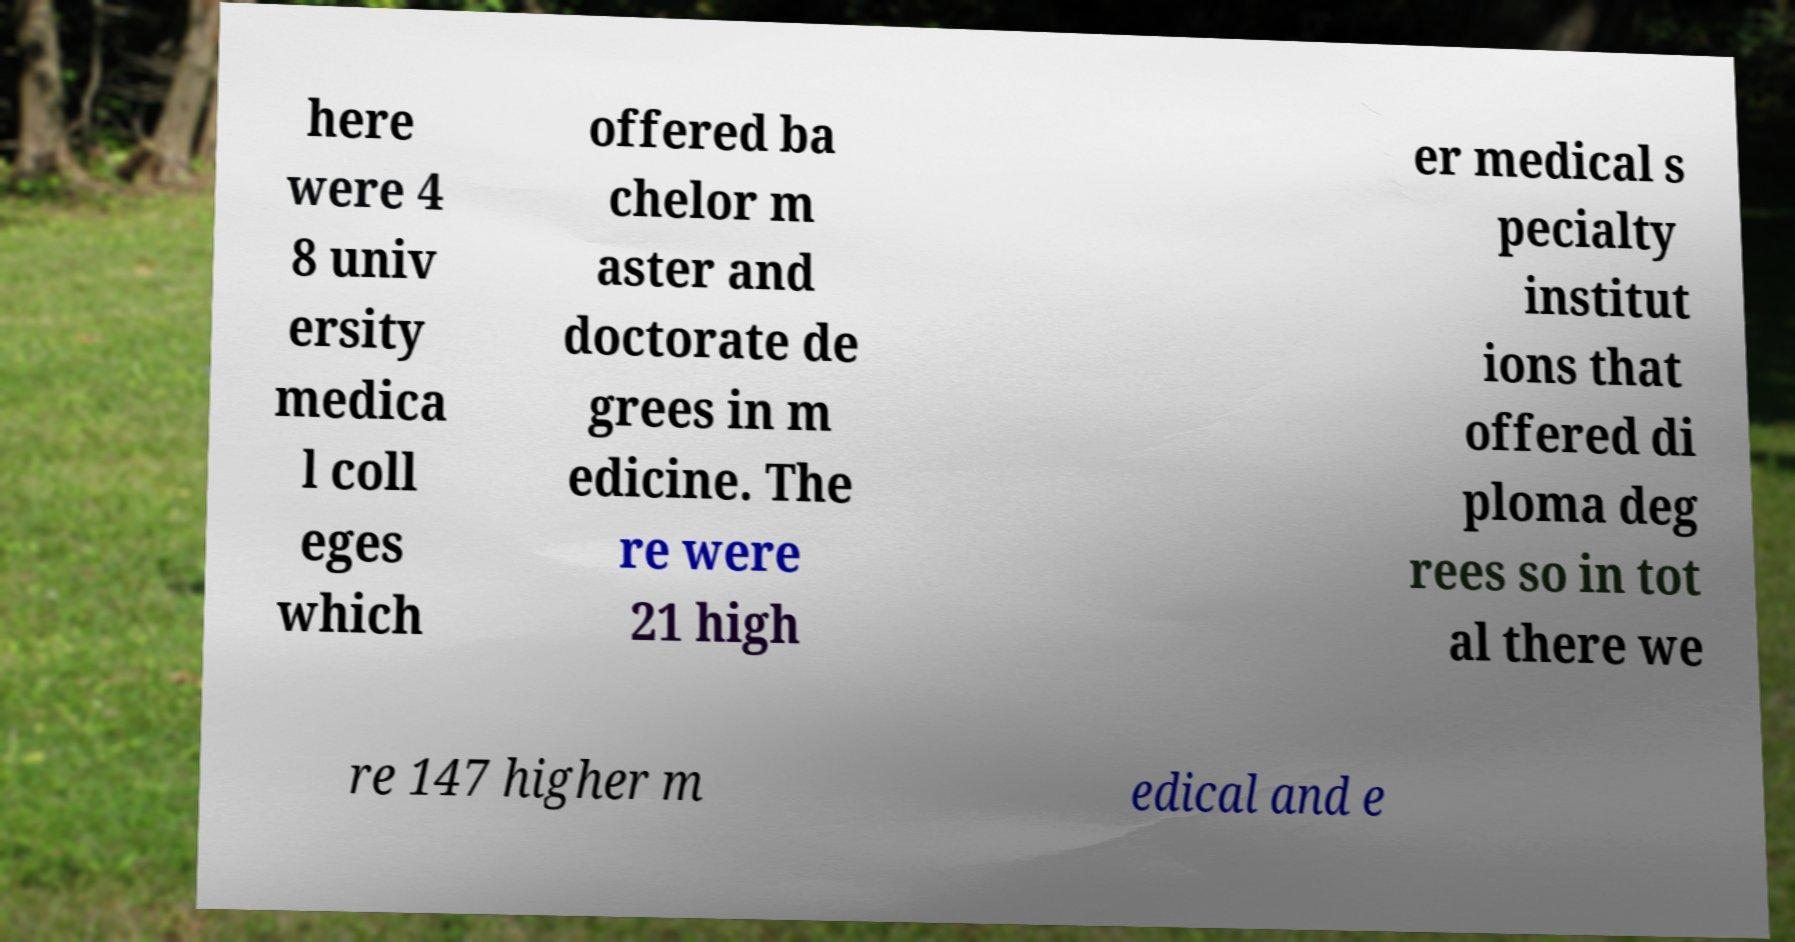Can you accurately transcribe the text from the provided image for me? here were 4 8 univ ersity medica l coll eges which offered ba chelor m aster and doctorate de grees in m edicine. The re were 21 high er medical s pecialty institut ions that offered di ploma deg rees so in tot al there we re 147 higher m edical and e 